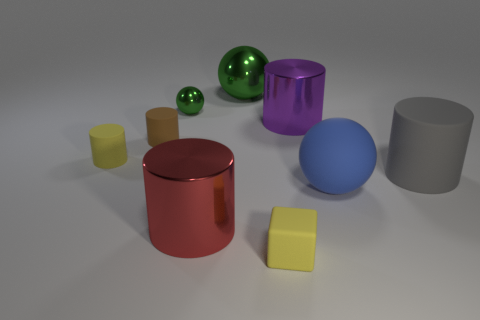Subtract 1 cylinders. How many cylinders are left? 4 Subtract all purple cylinders. How many cylinders are left? 4 Subtract all big red cylinders. How many cylinders are left? 4 Subtract all green cylinders. Subtract all yellow balls. How many cylinders are left? 5 Add 1 large red things. How many objects exist? 10 Subtract all spheres. How many objects are left? 6 Add 2 large shiny spheres. How many large shiny spheres are left? 3 Add 8 big matte cylinders. How many big matte cylinders exist? 9 Subtract 1 yellow blocks. How many objects are left? 8 Subtract all tiny yellow rubber cylinders. Subtract all yellow objects. How many objects are left? 6 